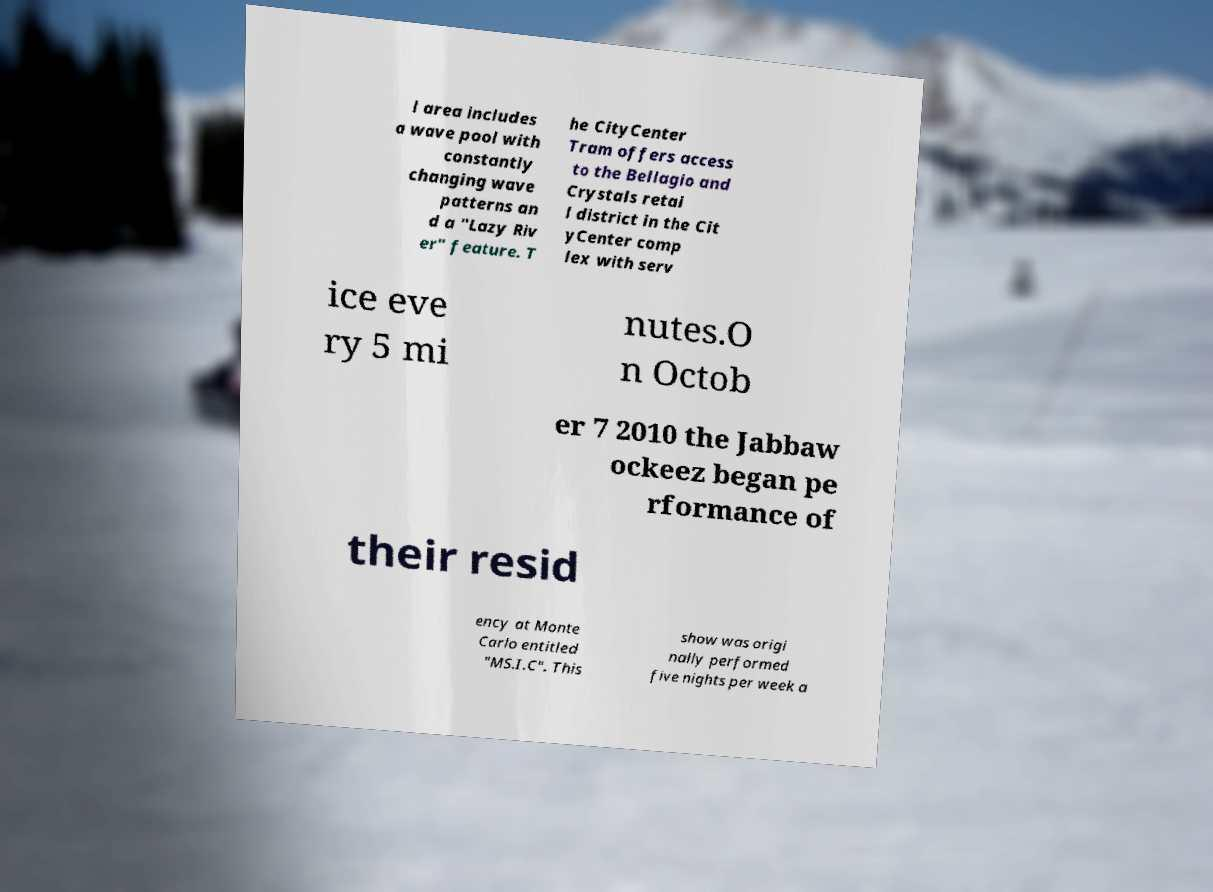Can you read and provide the text displayed in the image?This photo seems to have some interesting text. Can you extract and type it out for me? l area includes a wave pool with constantly changing wave patterns an d a "Lazy Riv er" feature. T he CityCenter Tram offers access to the Bellagio and Crystals retai l district in the Cit yCenter comp lex with serv ice eve ry 5 mi nutes.O n Octob er 7 2010 the Jabbaw ockeez began pe rformance of their resid ency at Monte Carlo entitled "MS.I.C". This show was origi nally performed five nights per week a 